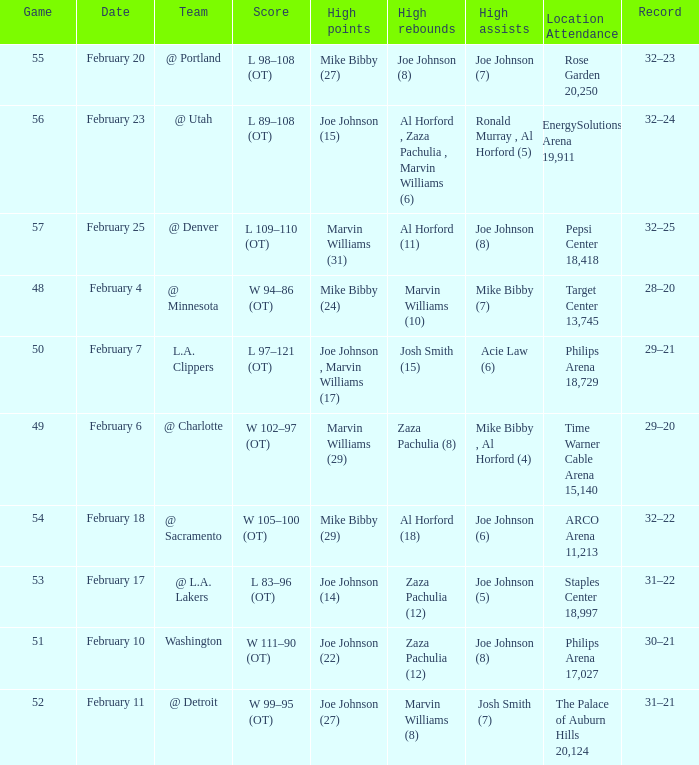Who made high assists on february 4 Mike Bibby (7). 